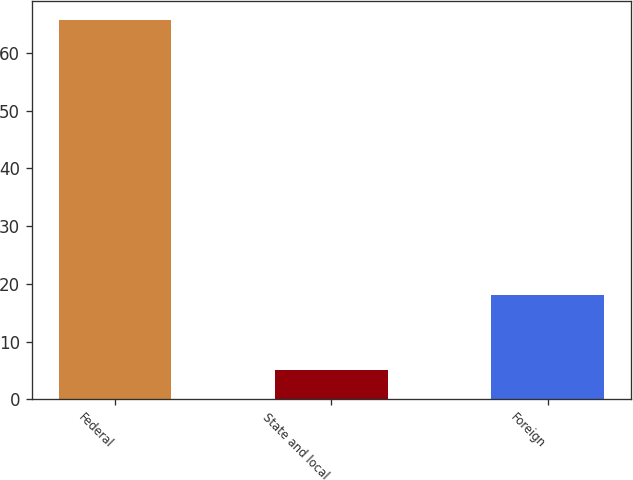Convert chart to OTSL. <chart><loc_0><loc_0><loc_500><loc_500><bar_chart><fcel>Federal<fcel>State and local<fcel>Foreign<nl><fcel>65.7<fcel>5.1<fcel>18<nl></chart> 